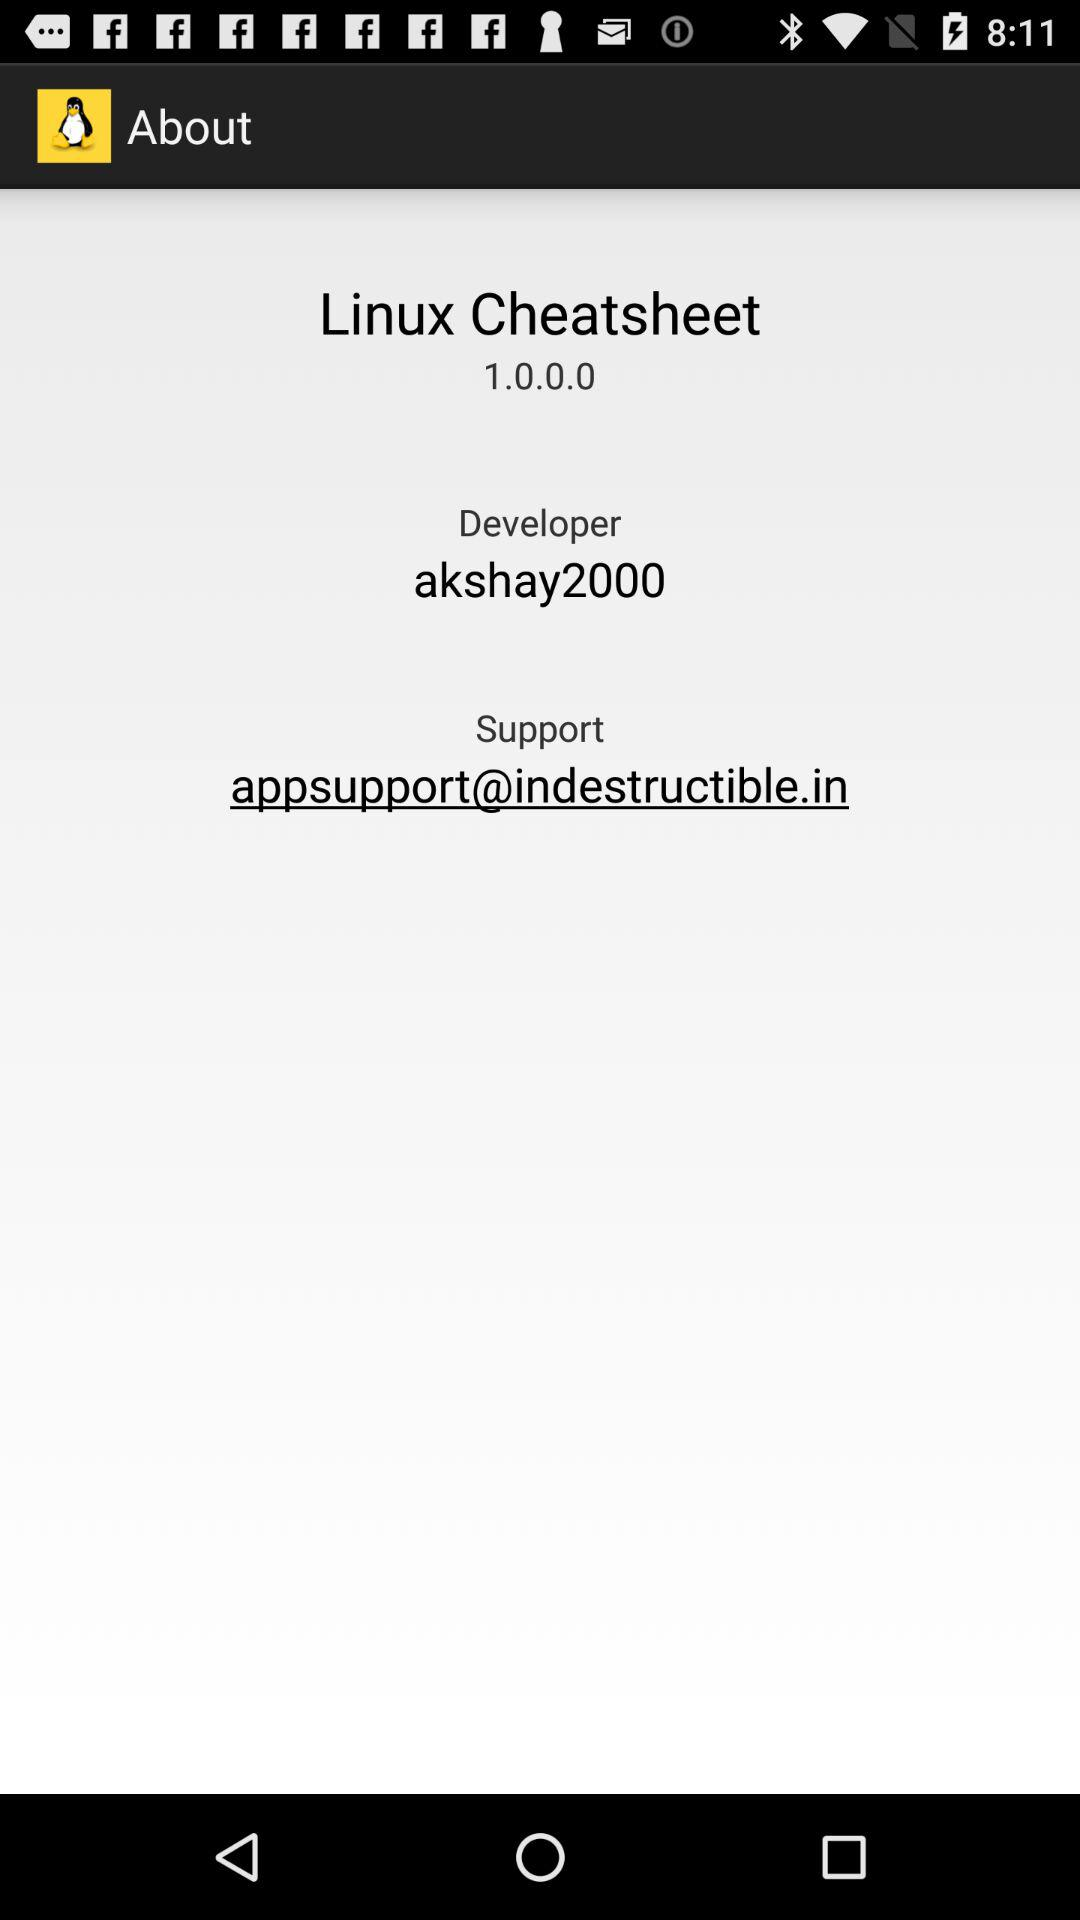What is the email address for support? The email address for support is appsupport@indestructible.in. 